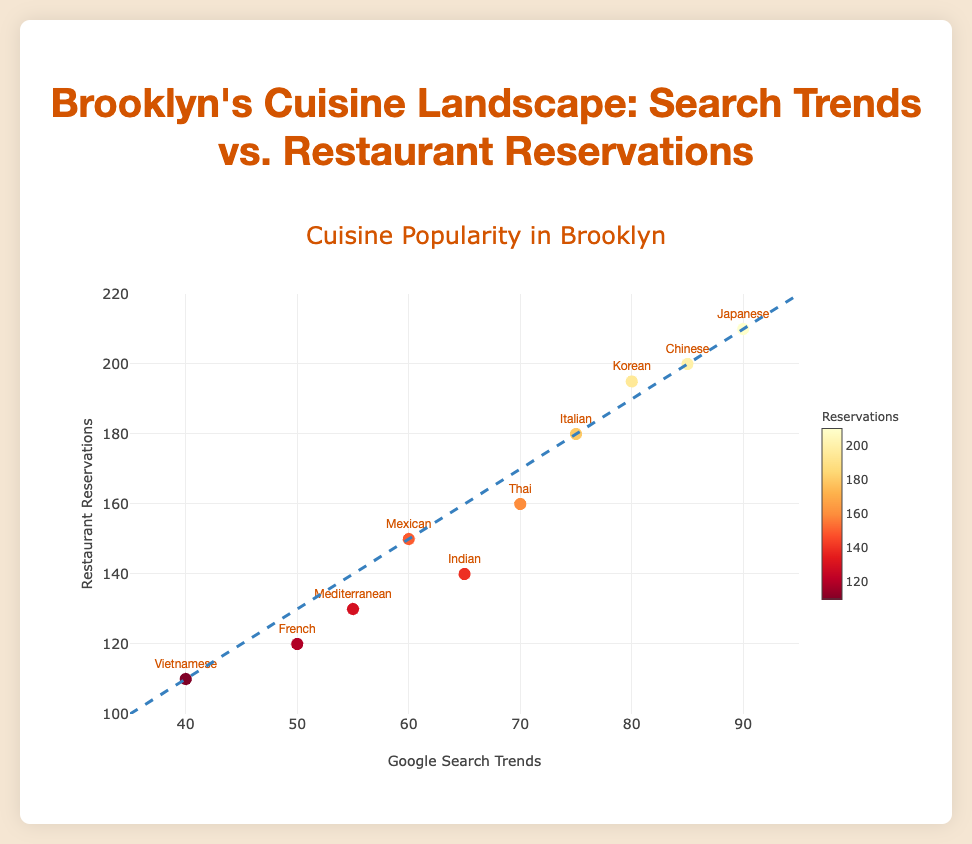How many cuisines are represented in the scatter plot? Count the number of different cuisines listed in the data points (each represented once in the plot). There are 10 data points representing 10 different cuisines.
Answer: 10 What is the title of the scatter plot? Look at the title displayed at the top of the scatter plot. It reads "Cuisine Popularity in Brooklyn".
Answer: Cuisine Popularity in Brooklyn Which cuisine has the highest value for Google Search Trends? Compare the Google Search Trends values for each cuisine. Japanese has the highest value at 90.
Answer: Japanese Which cuisine has the lowest number of restaurant reservations? Compare the restaurant reservations for each cuisine. Vietnamese has the lowest value with 110 reservations.
Answer: Vietnamese What is the range of the x-axis in the scatter plot? Observe the values shown on the x-axis. The range goes from 35 to 95.
Answer: 35 to 95 What is the range of the y-axis in the scatter plot? Observe the values shown on the y-axis. The range goes from 100 to 220.
Answer: 100 to 220 How many cuisines have Google Search Trends above 80? Check each cuisine's Google Search Trends value and count those above 80. Chinese, Japanese, and Korean are above 80.
Answer: 3 Compare the restaurant reservations between Mexican and Indian cuisines. Which one has more reservations? Look at the restaurant reservations values for Mexican (150) and Indian (140). Mexican has more reservations.
Answer: Mexican Which cuisine's data point lies closest to the trend line? Observe the positions of the data points relative to the trend line. The Japanese cuisine's data point is closest to the trend line.
Answer: Japanese What is the color representing the highest number of restaurant reservations on the scatter plot? Identify the color in the color bar associated with the highest reservation numbers. The color is a darker shade of red.
Answer: Dark red 